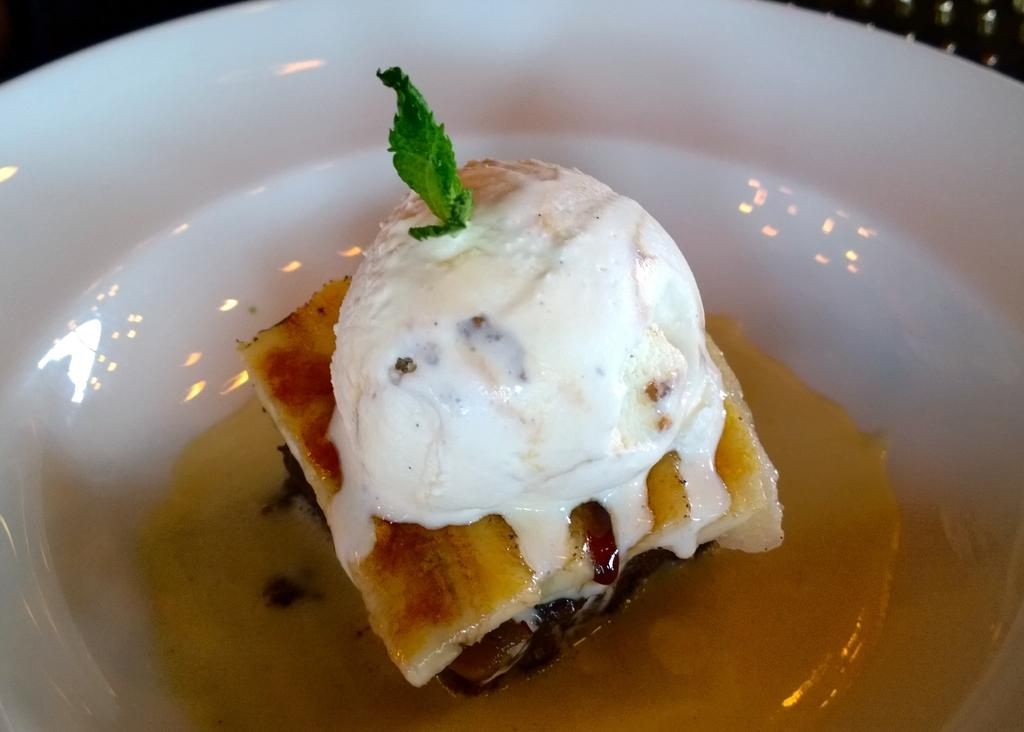What is the main object in the center of the image? There is a bowl in the center of the image. What is inside the bowl? The bowl contains a mint leaf, ice cream, and some food items. Can you describe any other objects visible in the background of the image? Unfortunately, the provided facts do not mention any specific objects visible in the background. How many horses are visible in the image? There are no horses present in the image. What type of kettle is used to prepare the food items in the image? There is no kettle present in the image, and the provided facts do not mention any food preparation. 